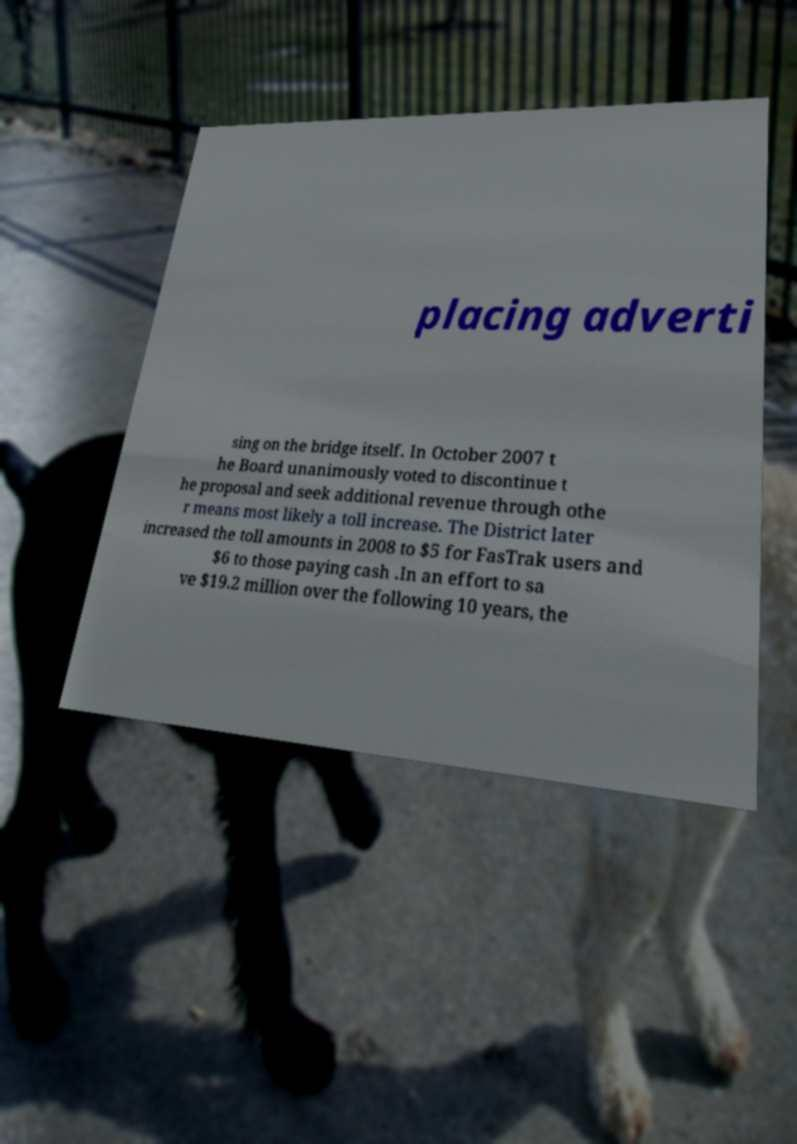What messages or text are displayed in this image? I need them in a readable, typed format. placing adverti sing on the bridge itself. In October 2007 t he Board unanimously voted to discontinue t he proposal and seek additional revenue through othe r means most likely a toll increase. The District later increased the toll amounts in 2008 to $5 for FasTrak users and $6 to those paying cash .In an effort to sa ve $19.2 million over the following 10 years, the 